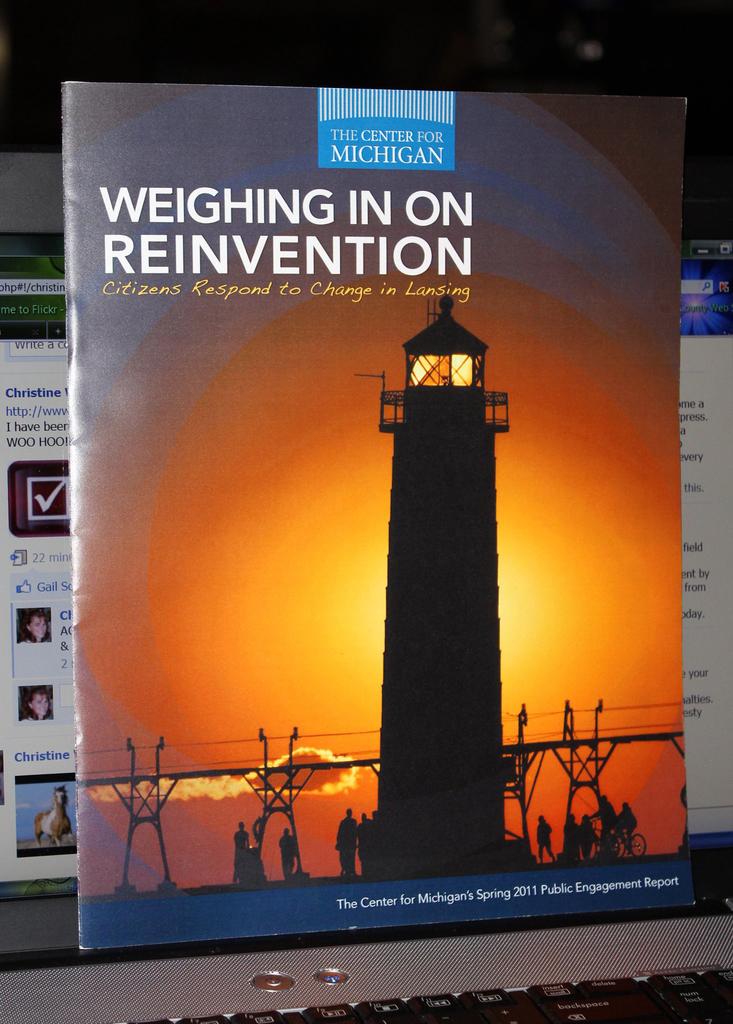What are they weighing in on?
Offer a very short reply. Reinvention. What year is the magazine from?
Your answer should be very brief. 2011. 